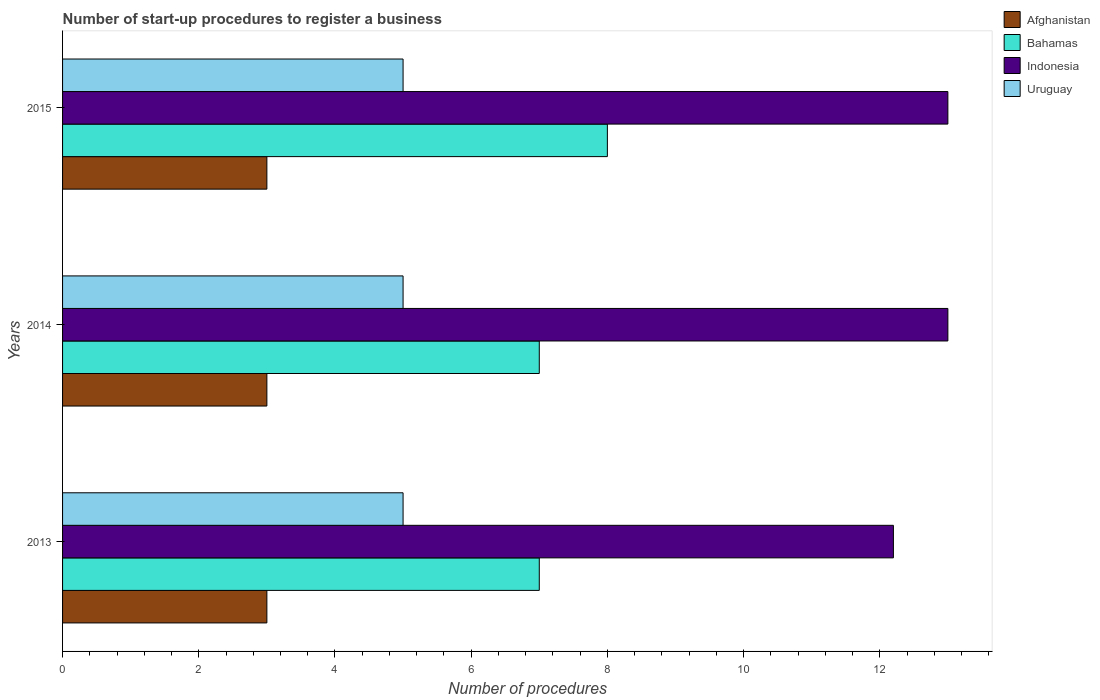How many different coloured bars are there?
Give a very brief answer. 4. Are the number of bars per tick equal to the number of legend labels?
Offer a very short reply. Yes. What is the label of the 1st group of bars from the top?
Your answer should be very brief. 2015. What is the number of procedures required to register a business in Indonesia in 2014?
Make the answer very short. 13. Across all years, what is the minimum number of procedures required to register a business in Uruguay?
Offer a very short reply. 5. In which year was the number of procedures required to register a business in Bahamas maximum?
Ensure brevity in your answer.  2015. What is the total number of procedures required to register a business in Uruguay in the graph?
Provide a succinct answer. 15. What is the difference between the number of procedures required to register a business in Indonesia in 2014 and the number of procedures required to register a business in Afghanistan in 2013?
Your response must be concise. 10. What is the average number of procedures required to register a business in Afghanistan per year?
Give a very brief answer. 3. What is the ratio of the number of procedures required to register a business in Uruguay in 2013 to that in 2015?
Offer a terse response. 1. Is the number of procedures required to register a business in Bahamas in 2013 less than that in 2014?
Your response must be concise. No. Is the difference between the number of procedures required to register a business in Afghanistan in 2013 and 2014 greater than the difference between the number of procedures required to register a business in Indonesia in 2013 and 2014?
Provide a short and direct response. Yes. In how many years, is the number of procedures required to register a business in Bahamas greater than the average number of procedures required to register a business in Bahamas taken over all years?
Your response must be concise. 1. Is it the case that in every year, the sum of the number of procedures required to register a business in Afghanistan and number of procedures required to register a business in Bahamas is greater than the sum of number of procedures required to register a business in Uruguay and number of procedures required to register a business in Indonesia?
Your answer should be very brief. No. What does the 4th bar from the top in 2015 represents?
Your answer should be very brief. Afghanistan. What does the 3rd bar from the bottom in 2014 represents?
Ensure brevity in your answer.  Indonesia. Does the graph contain grids?
Your answer should be compact. No. Where does the legend appear in the graph?
Offer a terse response. Top right. How are the legend labels stacked?
Make the answer very short. Vertical. What is the title of the graph?
Ensure brevity in your answer.  Number of start-up procedures to register a business. Does "Micronesia" appear as one of the legend labels in the graph?
Keep it short and to the point. No. What is the label or title of the X-axis?
Offer a terse response. Number of procedures. What is the label or title of the Y-axis?
Keep it short and to the point. Years. What is the Number of procedures in Afghanistan in 2013?
Give a very brief answer. 3. What is the Number of procedures in Indonesia in 2013?
Keep it short and to the point. 12.2. What is the Number of procedures in Uruguay in 2013?
Your answer should be compact. 5. What is the Number of procedures in Afghanistan in 2014?
Your answer should be very brief. 3. What is the Number of procedures in Bahamas in 2014?
Provide a succinct answer. 7. What is the Number of procedures of Uruguay in 2015?
Your response must be concise. 5. Across all years, what is the maximum Number of procedures of Indonesia?
Offer a very short reply. 13. Across all years, what is the maximum Number of procedures of Uruguay?
Offer a terse response. 5. Across all years, what is the minimum Number of procedures in Indonesia?
Offer a terse response. 12.2. Across all years, what is the minimum Number of procedures in Uruguay?
Give a very brief answer. 5. What is the total Number of procedures of Bahamas in the graph?
Your response must be concise. 22. What is the total Number of procedures in Indonesia in the graph?
Your response must be concise. 38.2. What is the total Number of procedures of Uruguay in the graph?
Your answer should be very brief. 15. What is the difference between the Number of procedures of Bahamas in 2013 and that in 2014?
Keep it short and to the point. 0. What is the difference between the Number of procedures of Afghanistan in 2013 and that in 2015?
Make the answer very short. 0. What is the difference between the Number of procedures of Bahamas in 2013 and that in 2015?
Make the answer very short. -1. What is the difference between the Number of procedures in Afghanistan in 2014 and that in 2015?
Keep it short and to the point. 0. What is the difference between the Number of procedures in Bahamas in 2014 and that in 2015?
Ensure brevity in your answer.  -1. What is the difference between the Number of procedures of Indonesia in 2014 and that in 2015?
Provide a succinct answer. 0. What is the difference between the Number of procedures in Afghanistan in 2013 and the Number of procedures in Indonesia in 2014?
Your response must be concise. -10. What is the difference between the Number of procedures in Afghanistan in 2013 and the Number of procedures in Uruguay in 2014?
Offer a very short reply. -2. What is the difference between the Number of procedures of Indonesia in 2013 and the Number of procedures of Uruguay in 2014?
Your answer should be very brief. 7.2. What is the difference between the Number of procedures in Afghanistan in 2013 and the Number of procedures in Bahamas in 2015?
Provide a succinct answer. -5. What is the difference between the Number of procedures of Bahamas in 2013 and the Number of procedures of Indonesia in 2015?
Offer a terse response. -6. What is the difference between the Number of procedures in Indonesia in 2013 and the Number of procedures in Uruguay in 2015?
Offer a terse response. 7.2. What is the difference between the Number of procedures in Afghanistan in 2014 and the Number of procedures in Bahamas in 2015?
Offer a very short reply. -5. What is the difference between the Number of procedures in Bahamas in 2014 and the Number of procedures in Indonesia in 2015?
Your answer should be very brief. -6. What is the difference between the Number of procedures of Bahamas in 2014 and the Number of procedures of Uruguay in 2015?
Give a very brief answer. 2. What is the average Number of procedures of Bahamas per year?
Give a very brief answer. 7.33. What is the average Number of procedures of Indonesia per year?
Give a very brief answer. 12.73. What is the average Number of procedures of Uruguay per year?
Offer a terse response. 5. In the year 2013, what is the difference between the Number of procedures of Afghanistan and Number of procedures of Bahamas?
Your answer should be compact. -4. In the year 2013, what is the difference between the Number of procedures in Afghanistan and Number of procedures in Uruguay?
Give a very brief answer. -2. In the year 2013, what is the difference between the Number of procedures in Bahamas and Number of procedures in Indonesia?
Your answer should be very brief. -5.2. In the year 2013, what is the difference between the Number of procedures of Indonesia and Number of procedures of Uruguay?
Give a very brief answer. 7.2. In the year 2014, what is the difference between the Number of procedures in Afghanistan and Number of procedures in Bahamas?
Your answer should be compact. -4. In the year 2014, what is the difference between the Number of procedures in Afghanistan and Number of procedures in Indonesia?
Make the answer very short. -10. In the year 2014, what is the difference between the Number of procedures of Afghanistan and Number of procedures of Uruguay?
Provide a succinct answer. -2. In the year 2014, what is the difference between the Number of procedures of Bahamas and Number of procedures of Indonesia?
Keep it short and to the point. -6. In the year 2014, what is the difference between the Number of procedures in Bahamas and Number of procedures in Uruguay?
Ensure brevity in your answer.  2. In the year 2015, what is the difference between the Number of procedures of Afghanistan and Number of procedures of Bahamas?
Provide a succinct answer. -5. In the year 2015, what is the difference between the Number of procedures in Bahamas and Number of procedures in Indonesia?
Make the answer very short. -5. In the year 2015, what is the difference between the Number of procedures of Indonesia and Number of procedures of Uruguay?
Your answer should be very brief. 8. What is the ratio of the Number of procedures of Indonesia in 2013 to that in 2014?
Your answer should be very brief. 0.94. What is the ratio of the Number of procedures of Uruguay in 2013 to that in 2014?
Offer a terse response. 1. What is the ratio of the Number of procedures in Indonesia in 2013 to that in 2015?
Your answer should be very brief. 0.94. What is the ratio of the Number of procedures in Uruguay in 2013 to that in 2015?
Your answer should be very brief. 1. What is the ratio of the Number of procedures in Indonesia in 2014 to that in 2015?
Provide a succinct answer. 1. What is the difference between the highest and the second highest Number of procedures of Afghanistan?
Your response must be concise. 0. What is the difference between the highest and the second highest Number of procedures in Bahamas?
Keep it short and to the point. 1. What is the difference between the highest and the second highest Number of procedures in Indonesia?
Your answer should be very brief. 0. What is the difference between the highest and the second highest Number of procedures of Uruguay?
Give a very brief answer. 0. What is the difference between the highest and the lowest Number of procedures in Bahamas?
Provide a short and direct response. 1. 